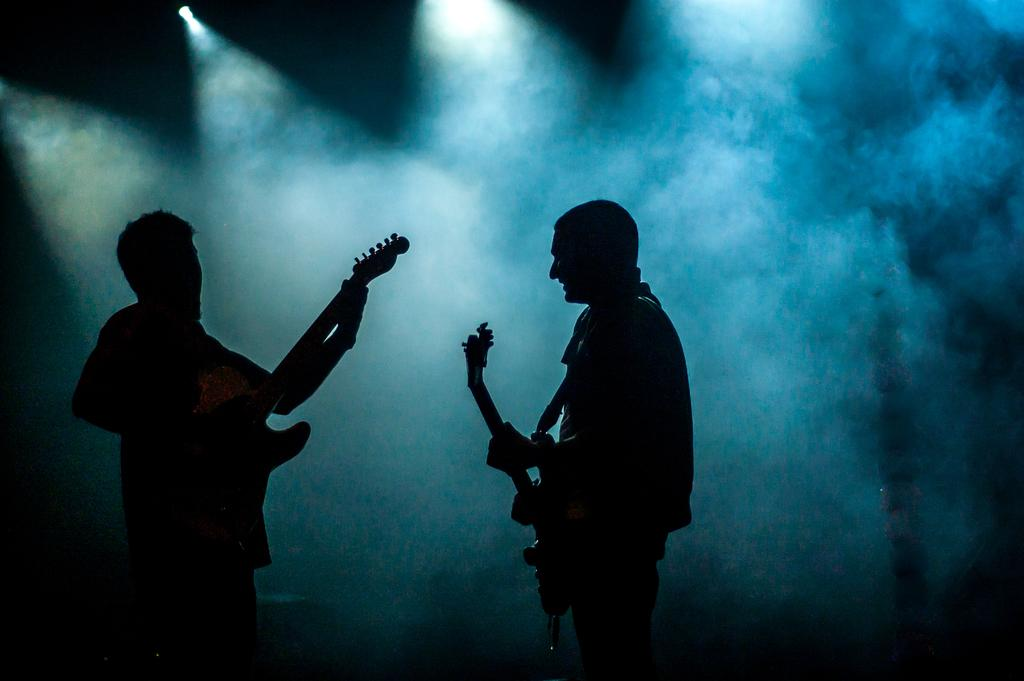How many people are in the image? There are two persons in the image. What are the persons doing in the image? The persons are standing and holding guitars. What can be seen in the background of the image? There is light and smoke in the background of the image. What type of flesh can be seen in the image? There is no flesh visible in the image; it features two persons holding guitars. Does the existence of the persons in the image prove the existence of extraterrestrial life? The image does not provide any information about extraterrestrial life, and the existence of the persons in the image cannot be used to prove or disprove the existence of extraterrestrial life. 